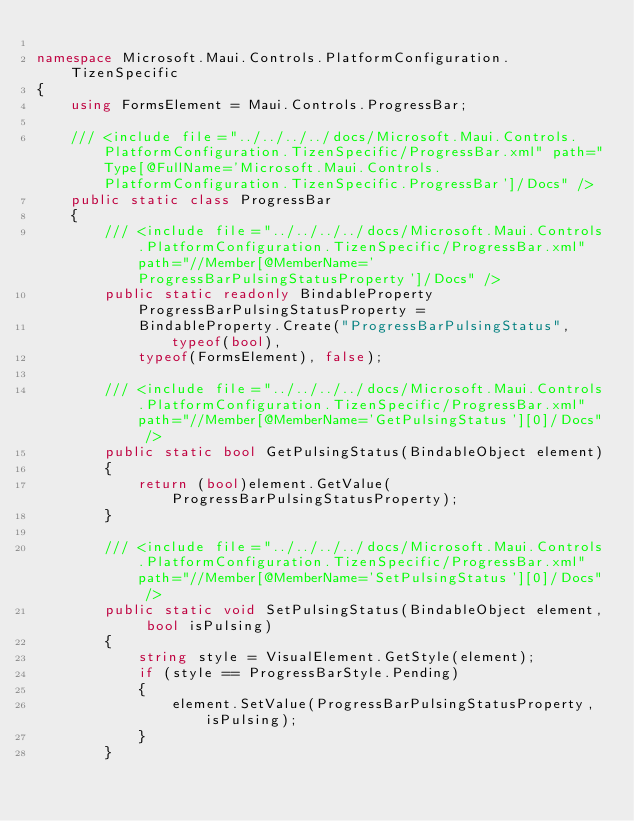Convert code to text. <code><loc_0><loc_0><loc_500><loc_500><_C#_>
namespace Microsoft.Maui.Controls.PlatformConfiguration.TizenSpecific
{
	using FormsElement = Maui.Controls.ProgressBar;

	/// <include file="../../../../docs/Microsoft.Maui.Controls.PlatformConfiguration.TizenSpecific/ProgressBar.xml" path="Type[@FullName='Microsoft.Maui.Controls.PlatformConfiguration.TizenSpecific.ProgressBar']/Docs" />
	public static class ProgressBar
	{
		/// <include file="../../../../docs/Microsoft.Maui.Controls.PlatformConfiguration.TizenSpecific/ProgressBar.xml" path="//Member[@MemberName='ProgressBarPulsingStatusProperty']/Docs" />
		public static readonly BindableProperty ProgressBarPulsingStatusProperty =
			BindableProperty.Create("ProgressBarPulsingStatus", typeof(bool),
			typeof(FormsElement), false);

		/// <include file="../../../../docs/Microsoft.Maui.Controls.PlatformConfiguration.TizenSpecific/ProgressBar.xml" path="//Member[@MemberName='GetPulsingStatus'][0]/Docs" />
		public static bool GetPulsingStatus(BindableObject element)
		{
			return (bool)element.GetValue(ProgressBarPulsingStatusProperty);
		}

		/// <include file="../../../../docs/Microsoft.Maui.Controls.PlatformConfiguration.TizenSpecific/ProgressBar.xml" path="//Member[@MemberName='SetPulsingStatus'][0]/Docs" />
		public static void SetPulsingStatus(BindableObject element, bool isPulsing)
		{
			string style = VisualElement.GetStyle(element);
			if (style == ProgressBarStyle.Pending)
			{
				element.SetValue(ProgressBarPulsingStatusProperty, isPulsing);
			}
		}
</code> 